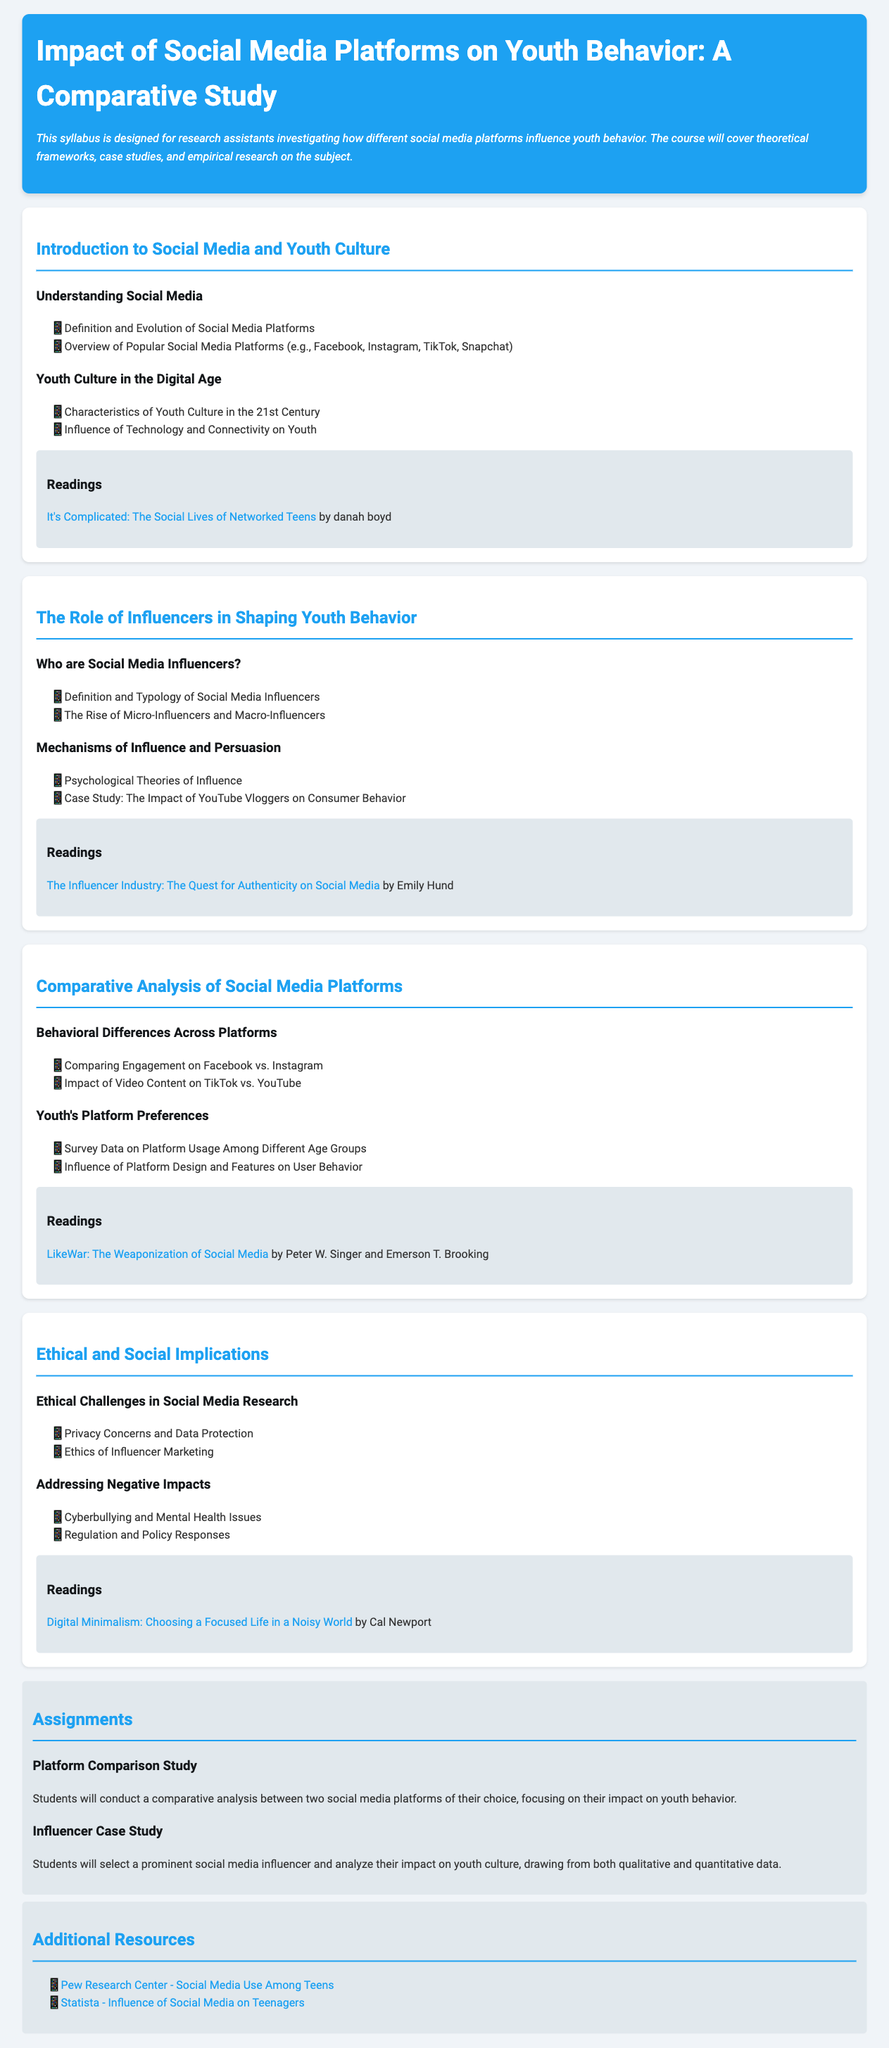What is the title of the syllabus? The title of the syllabus is explicitly stated at the beginning of the document.
Answer: Impact of Social Media Platforms on Youth Behavior: A Comparative Study Who is the author of "It's Complicated: The Social Lives of Networked Teens"? The reading list in the syllabus provides the author of the recommended book.
Answer: danah boyd What are the two types of social media influencers mentioned? The section discusses different types of influencers, specifically indicating two categories.
Answer: Micro-Influencers and Macro-Influencers Which social media platform is associated with "The weaponization of social media"? The readings section includes a specific book that mentions this phrase.
Answer: LikeWar What are the two ethical challenges addressed in the syllabus? The document outlines ethical challenges in social media research in a specific section.
Answer: Privacy Concerns and Data Protection How many assignments are listed in the syllabus? The assignments section details the total number of assignments included in the course.
Answer: 2 What is one of the topics covered in "Comparative Analysis of Social Media Platforms"? The topics listed under this section indicate specific subjects of study.
Answer: Behavioral Differences Across Platforms Who is the author of "Digital Minimalism"? The readings section provides the author's name of this recommended book.
Answer: Cal Newport 